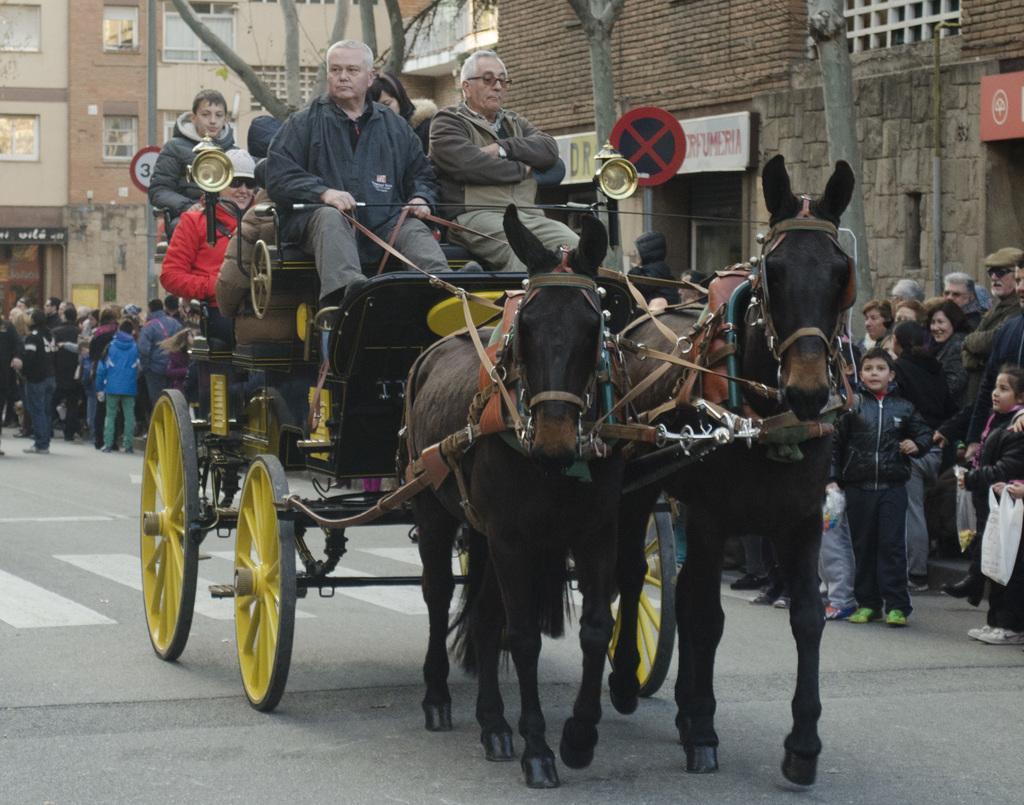How would you summarize this image in a sentence or two? In this picture I can see few people are standing, and I can see buildings and a board with some text and I can see a chariot and few people are sitting and I can see couple of horses and I can see few trees. 